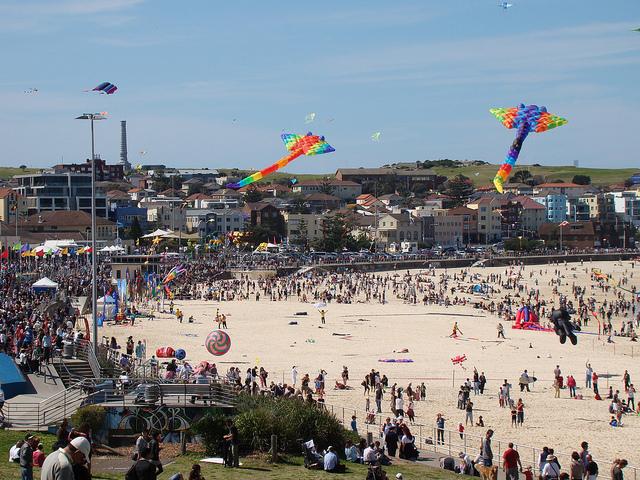Is there more grass or sand?
Write a very short answer. Sand. Is the beach crowded?
Give a very brief answer. Yes. What are the two brightly colored kites shaped to represent?
Answer briefly. Stingrays. 